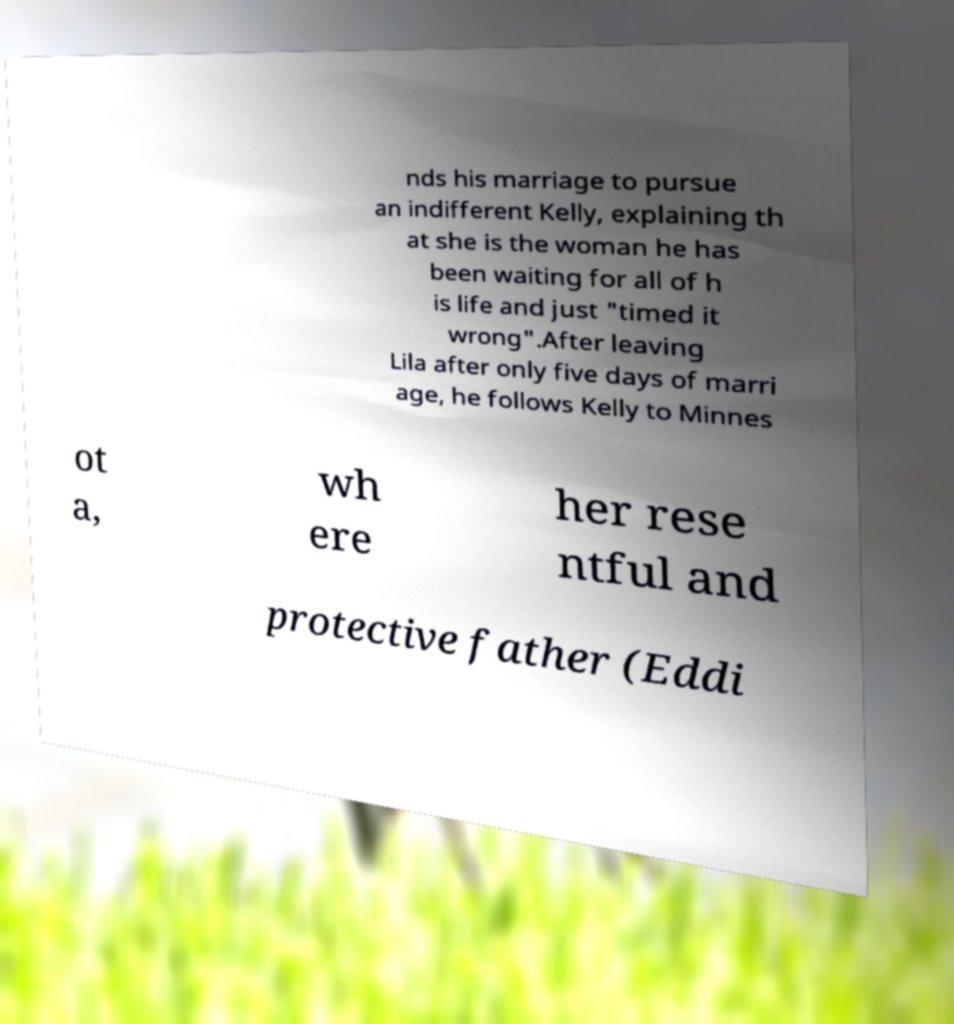Can you read and provide the text displayed in the image?This photo seems to have some interesting text. Can you extract and type it out for me? nds his marriage to pursue an indifferent Kelly, explaining th at she is the woman he has been waiting for all of h is life and just "timed it wrong".After leaving Lila after only five days of marri age, he follows Kelly to Minnes ot a, wh ere her rese ntful and protective father (Eddi 